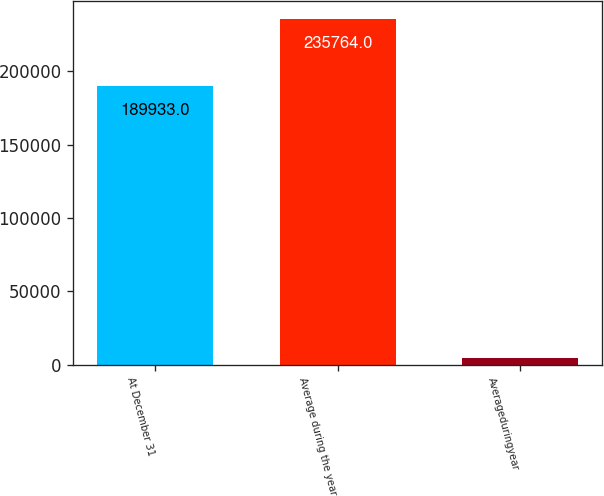Convert chart to OTSL. <chart><loc_0><loc_0><loc_500><loc_500><bar_chart><fcel>At December 31<fcel>Average during the year<fcel>Averageduringyear<nl><fcel>189933<fcel>235764<fcel>4239<nl></chart> 